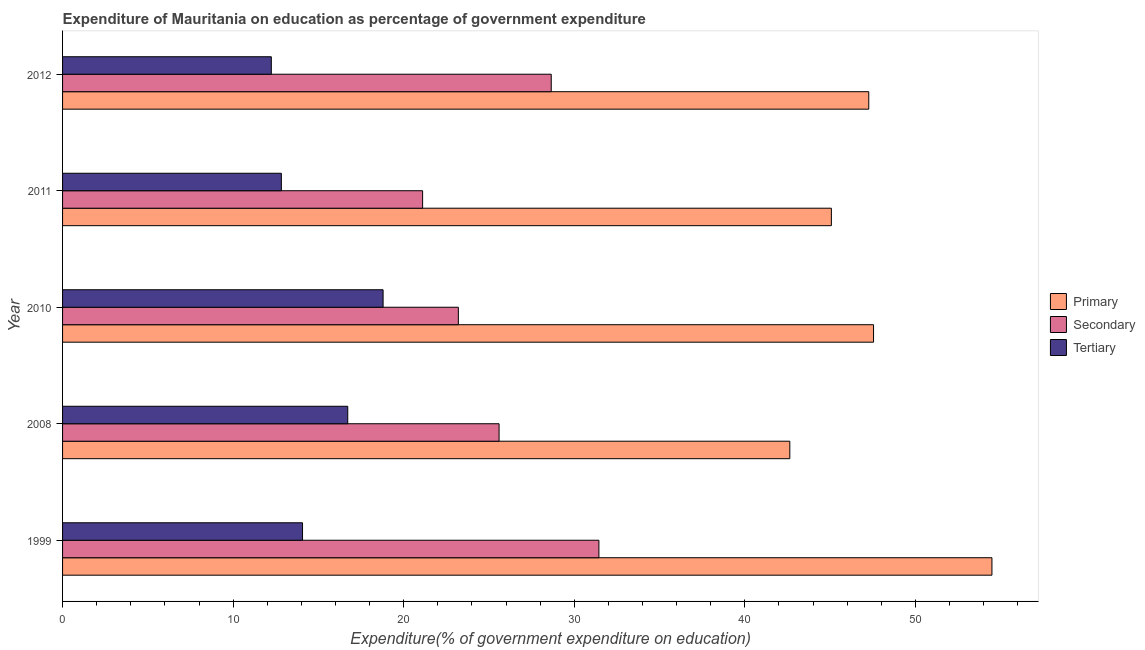How many groups of bars are there?
Make the answer very short. 5. Are the number of bars per tick equal to the number of legend labels?
Give a very brief answer. Yes. Are the number of bars on each tick of the Y-axis equal?
Your response must be concise. Yes. How many bars are there on the 4th tick from the top?
Provide a succinct answer. 3. How many bars are there on the 5th tick from the bottom?
Offer a very short reply. 3. What is the label of the 3rd group of bars from the top?
Keep it short and to the point. 2010. In how many cases, is the number of bars for a given year not equal to the number of legend labels?
Offer a very short reply. 0. What is the expenditure on secondary education in 2008?
Provide a succinct answer. 25.59. Across all years, what is the maximum expenditure on secondary education?
Keep it short and to the point. 31.44. Across all years, what is the minimum expenditure on secondary education?
Offer a very short reply. 21.11. In which year was the expenditure on secondary education maximum?
Keep it short and to the point. 1999. What is the total expenditure on secondary education in the graph?
Ensure brevity in your answer.  130. What is the difference between the expenditure on secondary education in 2011 and that in 2012?
Ensure brevity in your answer.  -7.54. What is the difference between the expenditure on primary education in 2011 and the expenditure on tertiary education in 2010?
Offer a very short reply. 26.28. What is the average expenditure on primary education per year?
Give a very brief answer. 47.4. In the year 1999, what is the difference between the expenditure on primary education and expenditure on secondary education?
Provide a short and direct response. 23.04. What is the ratio of the expenditure on secondary education in 2010 to that in 2012?
Provide a succinct answer. 0.81. What is the difference between the highest and the second highest expenditure on secondary education?
Your answer should be very brief. 2.79. What is the difference between the highest and the lowest expenditure on secondary education?
Your response must be concise. 10.34. What does the 1st bar from the top in 1999 represents?
Provide a succinct answer. Tertiary. What does the 2nd bar from the bottom in 1999 represents?
Provide a succinct answer. Secondary. How many bars are there?
Make the answer very short. 15. Are all the bars in the graph horizontal?
Your answer should be compact. Yes. How many years are there in the graph?
Your answer should be compact. 5. What is the difference between two consecutive major ticks on the X-axis?
Your answer should be very brief. 10. Are the values on the major ticks of X-axis written in scientific E-notation?
Offer a very short reply. No. Does the graph contain any zero values?
Keep it short and to the point. No. Does the graph contain grids?
Make the answer very short. No. How many legend labels are there?
Your answer should be compact. 3. What is the title of the graph?
Your response must be concise. Expenditure of Mauritania on education as percentage of government expenditure. Does "Ireland" appear as one of the legend labels in the graph?
Provide a short and direct response. No. What is the label or title of the X-axis?
Keep it short and to the point. Expenditure(% of government expenditure on education). What is the Expenditure(% of government expenditure on education) of Primary in 1999?
Your answer should be compact. 54.49. What is the Expenditure(% of government expenditure on education) of Secondary in 1999?
Keep it short and to the point. 31.44. What is the Expenditure(% of government expenditure on education) of Tertiary in 1999?
Your answer should be compact. 14.07. What is the Expenditure(% of government expenditure on education) of Primary in 2008?
Your answer should be very brief. 42.64. What is the Expenditure(% of government expenditure on education) in Secondary in 2008?
Make the answer very short. 25.59. What is the Expenditure(% of government expenditure on education) of Tertiary in 2008?
Your response must be concise. 16.72. What is the Expenditure(% of government expenditure on education) of Primary in 2010?
Provide a succinct answer. 47.55. What is the Expenditure(% of government expenditure on education) of Secondary in 2010?
Your answer should be very brief. 23.2. What is the Expenditure(% of government expenditure on education) in Tertiary in 2010?
Make the answer very short. 18.79. What is the Expenditure(% of government expenditure on education) in Primary in 2011?
Offer a terse response. 45.07. What is the Expenditure(% of government expenditure on education) of Secondary in 2011?
Keep it short and to the point. 21.11. What is the Expenditure(% of government expenditure on education) of Tertiary in 2011?
Your answer should be very brief. 12.83. What is the Expenditure(% of government expenditure on education) in Primary in 2012?
Give a very brief answer. 47.27. What is the Expenditure(% of government expenditure on education) in Secondary in 2012?
Make the answer very short. 28.65. What is the Expenditure(% of government expenditure on education) of Tertiary in 2012?
Make the answer very short. 12.24. Across all years, what is the maximum Expenditure(% of government expenditure on education) of Primary?
Provide a succinct answer. 54.49. Across all years, what is the maximum Expenditure(% of government expenditure on education) of Secondary?
Your answer should be very brief. 31.44. Across all years, what is the maximum Expenditure(% of government expenditure on education) of Tertiary?
Your answer should be compact. 18.79. Across all years, what is the minimum Expenditure(% of government expenditure on education) in Primary?
Your answer should be very brief. 42.64. Across all years, what is the minimum Expenditure(% of government expenditure on education) of Secondary?
Ensure brevity in your answer.  21.11. Across all years, what is the minimum Expenditure(% of government expenditure on education) in Tertiary?
Your response must be concise. 12.24. What is the total Expenditure(% of government expenditure on education) of Primary in the graph?
Keep it short and to the point. 237.01. What is the total Expenditure(% of government expenditure on education) of Secondary in the graph?
Your answer should be very brief. 130. What is the total Expenditure(% of government expenditure on education) in Tertiary in the graph?
Offer a very short reply. 74.65. What is the difference between the Expenditure(% of government expenditure on education) of Primary in 1999 and that in 2008?
Make the answer very short. 11.85. What is the difference between the Expenditure(% of government expenditure on education) in Secondary in 1999 and that in 2008?
Make the answer very short. 5.85. What is the difference between the Expenditure(% of government expenditure on education) in Tertiary in 1999 and that in 2008?
Your response must be concise. -2.65. What is the difference between the Expenditure(% of government expenditure on education) in Primary in 1999 and that in 2010?
Make the answer very short. 6.94. What is the difference between the Expenditure(% of government expenditure on education) of Secondary in 1999 and that in 2010?
Provide a short and direct response. 8.24. What is the difference between the Expenditure(% of government expenditure on education) in Tertiary in 1999 and that in 2010?
Make the answer very short. -4.72. What is the difference between the Expenditure(% of government expenditure on education) in Primary in 1999 and that in 2011?
Provide a short and direct response. 9.41. What is the difference between the Expenditure(% of government expenditure on education) of Secondary in 1999 and that in 2011?
Make the answer very short. 10.34. What is the difference between the Expenditure(% of government expenditure on education) in Tertiary in 1999 and that in 2011?
Provide a short and direct response. 1.24. What is the difference between the Expenditure(% of government expenditure on education) in Primary in 1999 and that in 2012?
Your answer should be very brief. 7.22. What is the difference between the Expenditure(% of government expenditure on education) in Secondary in 1999 and that in 2012?
Make the answer very short. 2.79. What is the difference between the Expenditure(% of government expenditure on education) of Tertiary in 1999 and that in 2012?
Your answer should be compact. 1.83. What is the difference between the Expenditure(% of government expenditure on education) of Primary in 2008 and that in 2010?
Your answer should be compact. -4.91. What is the difference between the Expenditure(% of government expenditure on education) of Secondary in 2008 and that in 2010?
Provide a succinct answer. 2.39. What is the difference between the Expenditure(% of government expenditure on education) in Tertiary in 2008 and that in 2010?
Make the answer very short. -2.07. What is the difference between the Expenditure(% of government expenditure on education) of Primary in 2008 and that in 2011?
Offer a very short reply. -2.44. What is the difference between the Expenditure(% of government expenditure on education) in Secondary in 2008 and that in 2011?
Make the answer very short. 4.48. What is the difference between the Expenditure(% of government expenditure on education) in Tertiary in 2008 and that in 2011?
Give a very brief answer. 3.89. What is the difference between the Expenditure(% of government expenditure on education) of Primary in 2008 and that in 2012?
Your answer should be very brief. -4.63. What is the difference between the Expenditure(% of government expenditure on education) of Secondary in 2008 and that in 2012?
Ensure brevity in your answer.  -3.06. What is the difference between the Expenditure(% of government expenditure on education) in Tertiary in 2008 and that in 2012?
Offer a terse response. 4.48. What is the difference between the Expenditure(% of government expenditure on education) in Primary in 2010 and that in 2011?
Keep it short and to the point. 2.47. What is the difference between the Expenditure(% of government expenditure on education) of Secondary in 2010 and that in 2011?
Your response must be concise. 2.1. What is the difference between the Expenditure(% of government expenditure on education) of Tertiary in 2010 and that in 2011?
Offer a very short reply. 5.96. What is the difference between the Expenditure(% of government expenditure on education) in Primary in 2010 and that in 2012?
Ensure brevity in your answer.  0.28. What is the difference between the Expenditure(% of government expenditure on education) in Secondary in 2010 and that in 2012?
Provide a succinct answer. -5.45. What is the difference between the Expenditure(% of government expenditure on education) of Tertiary in 2010 and that in 2012?
Make the answer very short. 6.55. What is the difference between the Expenditure(% of government expenditure on education) in Primary in 2011 and that in 2012?
Ensure brevity in your answer.  -2.19. What is the difference between the Expenditure(% of government expenditure on education) in Secondary in 2011 and that in 2012?
Your answer should be compact. -7.54. What is the difference between the Expenditure(% of government expenditure on education) in Tertiary in 2011 and that in 2012?
Offer a terse response. 0.59. What is the difference between the Expenditure(% of government expenditure on education) in Primary in 1999 and the Expenditure(% of government expenditure on education) in Secondary in 2008?
Give a very brief answer. 28.9. What is the difference between the Expenditure(% of government expenditure on education) of Primary in 1999 and the Expenditure(% of government expenditure on education) of Tertiary in 2008?
Your response must be concise. 37.77. What is the difference between the Expenditure(% of government expenditure on education) of Secondary in 1999 and the Expenditure(% of government expenditure on education) of Tertiary in 2008?
Give a very brief answer. 14.72. What is the difference between the Expenditure(% of government expenditure on education) of Primary in 1999 and the Expenditure(% of government expenditure on education) of Secondary in 2010?
Provide a short and direct response. 31.28. What is the difference between the Expenditure(% of government expenditure on education) in Primary in 1999 and the Expenditure(% of government expenditure on education) in Tertiary in 2010?
Keep it short and to the point. 35.69. What is the difference between the Expenditure(% of government expenditure on education) in Secondary in 1999 and the Expenditure(% of government expenditure on education) in Tertiary in 2010?
Provide a succinct answer. 12.65. What is the difference between the Expenditure(% of government expenditure on education) of Primary in 1999 and the Expenditure(% of government expenditure on education) of Secondary in 2011?
Offer a terse response. 33.38. What is the difference between the Expenditure(% of government expenditure on education) in Primary in 1999 and the Expenditure(% of government expenditure on education) in Tertiary in 2011?
Ensure brevity in your answer.  41.66. What is the difference between the Expenditure(% of government expenditure on education) of Secondary in 1999 and the Expenditure(% of government expenditure on education) of Tertiary in 2011?
Your answer should be compact. 18.62. What is the difference between the Expenditure(% of government expenditure on education) in Primary in 1999 and the Expenditure(% of government expenditure on education) in Secondary in 2012?
Give a very brief answer. 25.84. What is the difference between the Expenditure(% of government expenditure on education) in Primary in 1999 and the Expenditure(% of government expenditure on education) in Tertiary in 2012?
Offer a terse response. 42.25. What is the difference between the Expenditure(% of government expenditure on education) of Secondary in 1999 and the Expenditure(% of government expenditure on education) of Tertiary in 2012?
Provide a short and direct response. 19.21. What is the difference between the Expenditure(% of government expenditure on education) in Primary in 2008 and the Expenditure(% of government expenditure on education) in Secondary in 2010?
Your answer should be very brief. 19.43. What is the difference between the Expenditure(% of government expenditure on education) in Primary in 2008 and the Expenditure(% of government expenditure on education) in Tertiary in 2010?
Your answer should be compact. 23.84. What is the difference between the Expenditure(% of government expenditure on education) of Secondary in 2008 and the Expenditure(% of government expenditure on education) of Tertiary in 2010?
Provide a succinct answer. 6.8. What is the difference between the Expenditure(% of government expenditure on education) in Primary in 2008 and the Expenditure(% of government expenditure on education) in Secondary in 2011?
Your answer should be very brief. 21.53. What is the difference between the Expenditure(% of government expenditure on education) in Primary in 2008 and the Expenditure(% of government expenditure on education) in Tertiary in 2011?
Your response must be concise. 29.81. What is the difference between the Expenditure(% of government expenditure on education) of Secondary in 2008 and the Expenditure(% of government expenditure on education) of Tertiary in 2011?
Provide a short and direct response. 12.76. What is the difference between the Expenditure(% of government expenditure on education) of Primary in 2008 and the Expenditure(% of government expenditure on education) of Secondary in 2012?
Offer a very short reply. 13.99. What is the difference between the Expenditure(% of government expenditure on education) in Primary in 2008 and the Expenditure(% of government expenditure on education) in Tertiary in 2012?
Provide a short and direct response. 30.4. What is the difference between the Expenditure(% of government expenditure on education) of Secondary in 2008 and the Expenditure(% of government expenditure on education) of Tertiary in 2012?
Provide a short and direct response. 13.35. What is the difference between the Expenditure(% of government expenditure on education) in Primary in 2010 and the Expenditure(% of government expenditure on education) in Secondary in 2011?
Make the answer very short. 26.44. What is the difference between the Expenditure(% of government expenditure on education) of Primary in 2010 and the Expenditure(% of government expenditure on education) of Tertiary in 2011?
Your answer should be very brief. 34.72. What is the difference between the Expenditure(% of government expenditure on education) in Secondary in 2010 and the Expenditure(% of government expenditure on education) in Tertiary in 2011?
Your answer should be compact. 10.38. What is the difference between the Expenditure(% of government expenditure on education) of Primary in 2010 and the Expenditure(% of government expenditure on education) of Secondary in 2012?
Your answer should be compact. 18.9. What is the difference between the Expenditure(% of government expenditure on education) of Primary in 2010 and the Expenditure(% of government expenditure on education) of Tertiary in 2012?
Offer a very short reply. 35.31. What is the difference between the Expenditure(% of government expenditure on education) in Secondary in 2010 and the Expenditure(% of government expenditure on education) in Tertiary in 2012?
Your answer should be compact. 10.97. What is the difference between the Expenditure(% of government expenditure on education) of Primary in 2011 and the Expenditure(% of government expenditure on education) of Secondary in 2012?
Offer a terse response. 16.42. What is the difference between the Expenditure(% of government expenditure on education) in Primary in 2011 and the Expenditure(% of government expenditure on education) in Tertiary in 2012?
Provide a succinct answer. 32.83. What is the difference between the Expenditure(% of government expenditure on education) in Secondary in 2011 and the Expenditure(% of government expenditure on education) in Tertiary in 2012?
Provide a short and direct response. 8.87. What is the average Expenditure(% of government expenditure on education) of Primary per year?
Provide a succinct answer. 47.4. What is the average Expenditure(% of government expenditure on education) in Secondary per year?
Provide a succinct answer. 26. What is the average Expenditure(% of government expenditure on education) of Tertiary per year?
Your response must be concise. 14.93. In the year 1999, what is the difference between the Expenditure(% of government expenditure on education) in Primary and Expenditure(% of government expenditure on education) in Secondary?
Ensure brevity in your answer.  23.04. In the year 1999, what is the difference between the Expenditure(% of government expenditure on education) in Primary and Expenditure(% of government expenditure on education) in Tertiary?
Your answer should be compact. 40.42. In the year 1999, what is the difference between the Expenditure(% of government expenditure on education) in Secondary and Expenditure(% of government expenditure on education) in Tertiary?
Make the answer very short. 17.38. In the year 2008, what is the difference between the Expenditure(% of government expenditure on education) in Primary and Expenditure(% of government expenditure on education) in Secondary?
Offer a very short reply. 17.05. In the year 2008, what is the difference between the Expenditure(% of government expenditure on education) in Primary and Expenditure(% of government expenditure on education) in Tertiary?
Ensure brevity in your answer.  25.92. In the year 2008, what is the difference between the Expenditure(% of government expenditure on education) of Secondary and Expenditure(% of government expenditure on education) of Tertiary?
Your response must be concise. 8.87. In the year 2010, what is the difference between the Expenditure(% of government expenditure on education) of Primary and Expenditure(% of government expenditure on education) of Secondary?
Make the answer very short. 24.34. In the year 2010, what is the difference between the Expenditure(% of government expenditure on education) of Primary and Expenditure(% of government expenditure on education) of Tertiary?
Your answer should be very brief. 28.75. In the year 2010, what is the difference between the Expenditure(% of government expenditure on education) in Secondary and Expenditure(% of government expenditure on education) in Tertiary?
Provide a succinct answer. 4.41. In the year 2011, what is the difference between the Expenditure(% of government expenditure on education) in Primary and Expenditure(% of government expenditure on education) in Secondary?
Give a very brief answer. 23.96. In the year 2011, what is the difference between the Expenditure(% of government expenditure on education) in Primary and Expenditure(% of government expenditure on education) in Tertiary?
Your response must be concise. 32.25. In the year 2011, what is the difference between the Expenditure(% of government expenditure on education) in Secondary and Expenditure(% of government expenditure on education) in Tertiary?
Provide a short and direct response. 8.28. In the year 2012, what is the difference between the Expenditure(% of government expenditure on education) of Primary and Expenditure(% of government expenditure on education) of Secondary?
Provide a succinct answer. 18.62. In the year 2012, what is the difference between the Expenditure(% of government expenditure on education) in Primary and Expenditure(% of government expenditure on education) in Tertiary?
Provide a short and direct response. 35.03. In the year 2012, what is the difference between the Expenditure(% of government expenditure on education) in Secondary and Expenditure(% of government expenditure on education) in Tertiary?
Make the answer very short. 16.41. What is the ratio of the Expenditure(% of government expenditure on education) of Primary in 1999 to that in 2008?
Ensure brevity in your answer.  1.28. What is the ratio of the Expenditure(% of government expenditure on education) in Secondary in 1999 to that in 2008?
Your answer should be compact. 1.23. What is the ratio of the Expenditure(% of government expenditure on education) in Tertiary in 1999 to that in 2008?
Keep it short and to the point. 0.84. What is the ratio of the Expenditure(% of government expenditure on education) in Primary in 1999 to that in 2010?
Make the answer very short. 1.15. What is the ratio of the Expenditure(% of government expenditure on education) in Secondary in 1999 to that in 2010?
Offer a terse response. 1.36. What is the ratio of the Expenditure(% of government expenditure on education) of Tertiary in 1999 to that in 2010?
Your answer should be very brief. 0.75. What is the ratio of the Expenditure(% of government expenditure on education) of Primary in 1999 to that in 2011?
Provide a short and direct response. 1.21. What is the ratio of the Expenditure(% of government expenditure on education) of Secondary in 1999 to that in 2011?
Offer a terse response. 1.49. What is the ratio of the Expenditure(% of government expenditure on education) of Tertiary in 1999 to that in 2011?
Your answer should be very brief. 1.1. What is the ratio of the Expenditure(% of government expenditure on education) in Primary in 1999 to that in 2012?
Give a very brief answer. 1.15. What is the ratio of the Expenditure(% of government expenditure on education) of Secondary in 1999 to that in 2012?
Your answer should be very brief. 1.1. What is the ratio of the Expenditure(% of government expenditure on education) of Tertiary in 1999 to that in 2012?
Offer a terse response. 1.15. What is the ratio of the Expenditure(% of government expenditure on education) of Primary in 2008 to that in 2010?
Offer a very short reply. 0.9. What is the ratio of the Expenditure(% of government expenditure on education) of Secondary in 2008 to that in 2010?
Provide a succinct answer. 1.1. What is the ratio of the Expenditure(% of government expenditure on education) of Tertiary in 2008 to that in 2010?
Offer a very short reply. 0.89. What is the ratio of the Expenditure(% of government expenditure on education) in Primary in 2008 to that in 2011?
Give a very brief answer. 0.95. What is the ratio of the Expenditure(% of government expenditure on education) in Secondary in 2008 to that in 2011?
Give a very brief answer. 1.21. What is the ratio of the Expenditure(% of government expenditure on education) in Tertiary in 2008 to that in 2011?
Ensure brevity in your answer.  1.3. What is the ratio of the Expenditure(% of government expenditure on education) in Primary in 2008 to that in 2012?
Offer a terse response. 0.9. What is the ratio of the Expenditure(% of government expenditure on education) in Secondary in 2008 to that in 2012?
Your answer should be very brief. 0.89. What is the ratio of the Expenditure(% of government expenditure on education) in Tertiary in 2008 to that in 2012?
Offer a terse response. 1.37. What is the ratio of the Expenditure(% of government expenditure on education) of Primary in 2010 to that in 2011?
Give a very brief answer. 1.05. What is the ratio of the Expenditure(% of government expenditure on education) in Secondary in 2010 to that in 2011?
Give a very brief answer. 1.1. What is the ratio of the Expenditure(% of government expenditure on education) in Tertiary in 2010 to that in 2011?
Make the answer very short. 1.47. What is the ratio of the Expenditure(% of government expenditure on education) in Primary in 2010 to that in 2012?
Offer a terse response. 1.01. What is the ratio of the Expenditure(% of government expenditure on education) of Secondary in 2010 to that in 2012?
Give a very brief answer. 0.81. What is the ratio of the Expenditure(% of government expenditure on education) in Tertiary in 2010 to that in 2012?
Your answer should be compact. 1.54. What is the ratio of the Expenditure(% of government expenditure on education) of Primary in 2011 to that in 2012?
Give a very brief answer. 0.95. What is the ratio of the Expenditure(% of government expenditure on education) of Secondary in 2011 to that in 2012?
Provide a short and direct response. 0.74. What is the ratio of the Expenditure(% of government expenditure on education) in Tertiary in 2011 to that in 2012?
Provide a short and direct response. 1.05. What is the difference between the highest and the second highest Expenditure(% of government expenditure on education) in Primary?
Ensure brevity in your answer.  6.94. What is the difference between the highest and the second highest Expenditure(% of government expenditure on education) in Secondary?
Make the answer very short. 2.79. What is the difference between the highest and the second highest Expenditure(% of government expenditure on education) of Tertiary?
Your answer should be compact. 2.07. What is the difference between the highest and the lowest Expenditure(% of government expenditure on education) in Primary?
Your answer should be compact. 11.85. What is the difference between the highest and the lowest Expenditure(% of government expenditure on education) in Secondary?
Your answer should be compact. 10.34. What is the difference between the highest and the lowest Expenditure(% of government expenditure on education) in Tertiary?
Your response must be concise. 6.55. 